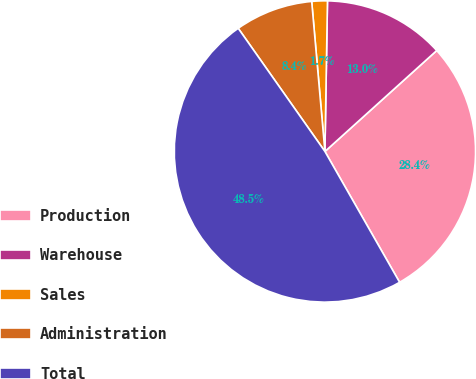Convert chart to OTSL. <chart><loc_0><loc_0><loc_500><loc_500><pie_chart><fcel>Production<fcel>Warehouse<fcel>Sales<fcel>Administration<fcel>Total<nl><fcel>28.43%<fcel>13.04%<fcel>1.67%<fcel>8.36%<fcel>48.49%<nl></chart> 